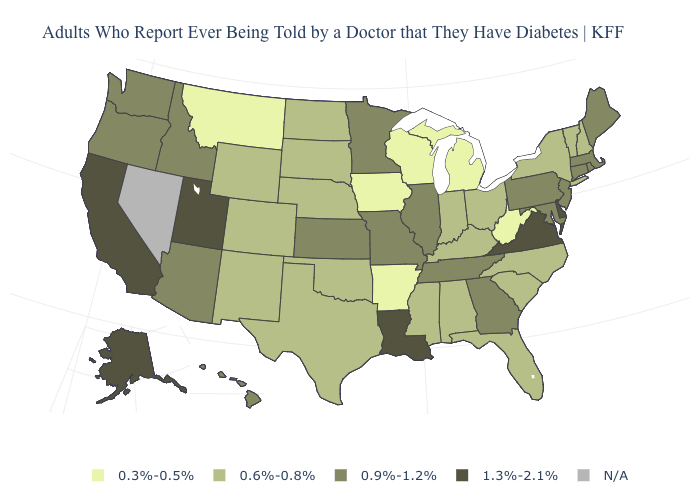Which states have the lowest value in the USA?
Be succinct. Arkansas, Iowa, Michigan, Montana, West Virginia, Wisconsin. What is the value of Oregon?
Quick response, please. 0.9%-1.2%. Name the states that have a value in the range 0.9%-1.2%?
Concise answer only. Arizona, Connecticut, Georgia, Hawaii, Idaho, Illinois, Kansas, Maine, Maryland, Massachusetts, Minnesota, Missouri, New Jersey, Oregon, Pennsylvania, Rhode Island, Tennessee, Washington. Name the states that have a value in the range 0.9%-1.2%?
Keep it brief. Arizona, Connecticut, Georgia, Hawaii, Idaho, Illinois, Kansas, Maine, Maryland, Massachusetts, Minnesota, Missouri, New Jersey, Oregon, Pennsylvania, Rhode Island, Tennessee, Washington. What is the value of Virginia?
Concise answer only. 1.3%-2.1%. Name the states that have a value in the range 1.3%-2.1%?
Keep it brief. Alaska, California, Delaware, Louisiana, Utah, Virginia. Name the states that have a value in the range 1.3%-2.1%?
Be succinct. Alaska, California, Delaware, Louisiana, Utah, Virginia. How many symbols are there in the legend?
Concise answer only. 5. Does Delaware have the highest value in the USA?
Write a very short answer. Yes. Name the states that have a value in the range 0.9%-1.2%?
Answer briefly. Arizona, Connecticut, Georgia, Hawaii, Idaho, Illinois, Kansas, Maine, Maryland, Massachusetts, Minnesota, Missouri, New Jersey, Oregon, Pennsylvania, Rhode Island, Tennessee, Washington. Name the states that have a value in the range 1.3%-2.1%?
Answer briefly. Alaska, California, Delaware, Louisiana, Utah, Virginia. Does the first symbol in the legend represent the smallest category?
Write a very short answer. Yes. How many symbols are there in the legend?
Short answer required. 5. Name the states that have a value in the range 0.3%-0.5%?
Keep it brief. Arkansas, Iowa, Michigan, Montana, West Virginia, Wisconsin. 